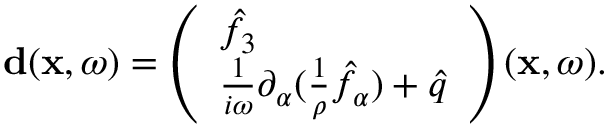Convert formula to latex. <formula><loc_0><loc_0><loc_500><loc_500>\begin{array} { r } { { d } ( { x } , \omega ) = \left ( \begin{array} { l } { \hat { f } _ { 3 } } \\ { \frac { 1 } { i \omega } \partial _ { \alpha } ( \frac { 1 } { \rho } \hat { f } _ { \alpha } ) + \hat { q } } \end{array} \right ) ( { x } , \omega ) . } \end{array}</formula> 